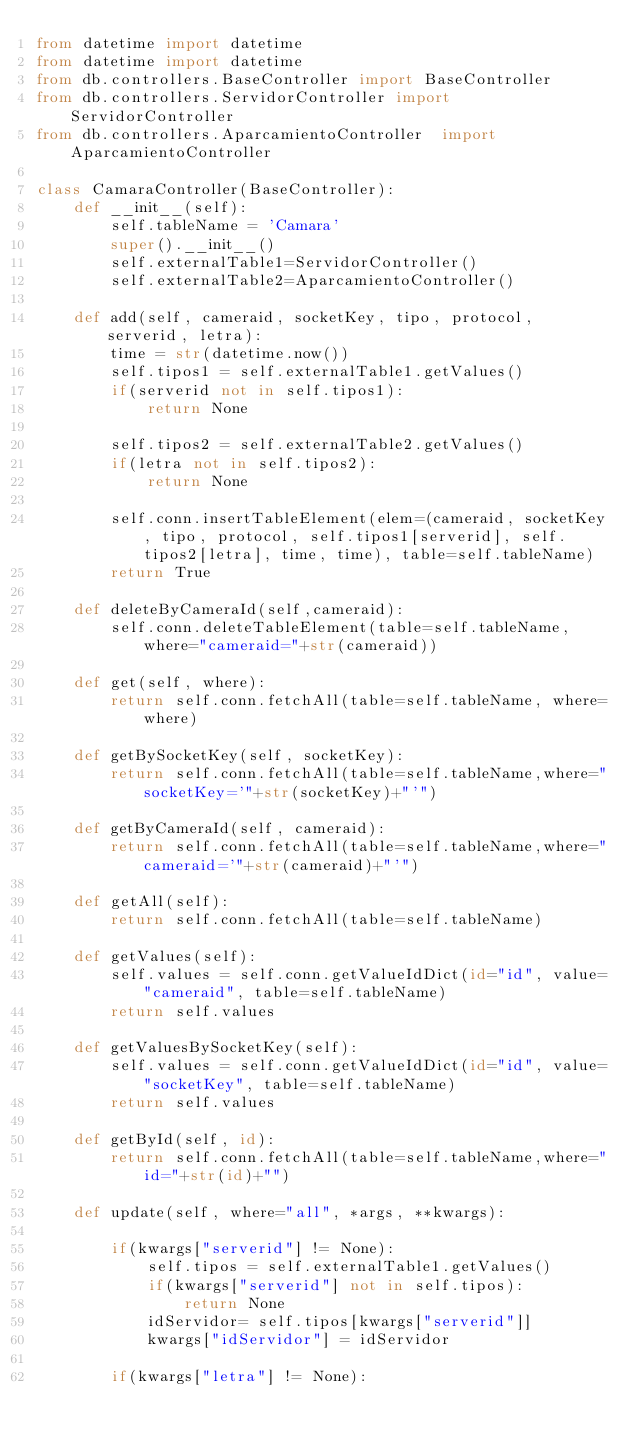<code> <loc_0><loc_0><loc_500><loc_500><_Python_>from datetime import datetime
from datetime import datetime
from db.controllers.BaseController import BaseController
from db.controllers.ServidorController import ServidorController
from db.controllers.AparcamientoController  import AparcamientoController 

class CamaraController(BaseController):
    def __init__(self):
        self.tableName = 'Camara'
        super().__init__()
        self.externalTable1=ServidorController()
        self.externalTable2=AparcamientoController()
        
    def add(self, cameraid, socketKey, tipo, protocol, serverid, letra):
        time = str(datetime.now())
        self.tipos1 = self.externalTable1.getValues()
        if(serverid not in self.tipos1):
            return None
        
        self.tipos2 = self.externalTable2.getValues()
        if(letra not in self.tipos2):
            return None
        
        self.conn.insertTableElement(elem=(cameraid, socketKey, tipo, protocol, self.tipos1[serverid], self.tipos2[letra], time, time), table=self.tableName)
        return True
    
    def deleteByCameraId(self,cameraid):
        self.conn.deleteTableElement(table=self.tableName, where="cameraid="+str(cameraid))
    
    def get(self, where):
        return self.conn.fetchAll(table=self.tableName, where=where)
    
    def getBySocketKey(self, socketKey):
        return self.conn.fetchAll(table=self.tableName,where="socketKey='"+str(socketKey)+"'")
    
    def getByCameraId(self, cameraid):
        return self.conn.fetchAll(table=self.tableName,where="cameraid='"+str(cameraid)+"'")      
    
    def getAll(self):
        return self.conn.fetchAll(table=self.tableName)
    
    def getValues(self):
        self.values = self.conn.getValueIdDict(id="id", value="cameraid", table=self.tableName)
        return self.values
    
    def getValuesBySocketKey(self):
        self.values = self.conn.getValueIdDict(id="id", value="socketKey", table=self.tableName)
        return self.values
    
    def getById(self, id):
        return self.conn.fetchAll(table=self.tableName,where="id="+str(id)+"")
                                  
    def update(self, where="all", *args, **kwargs):
    
        if(kwargs["serverid"] != None):
            self.tipos = self.externalTable1.getValues()
            if(kwargs["serverid"] not in self.tipos):
                return None
            idServidor= self.tipos[kwargs["serverid"]]
            kwargs["idServidor"] = idServidor
        
        if(kwargs["letra"] != None):</code> 